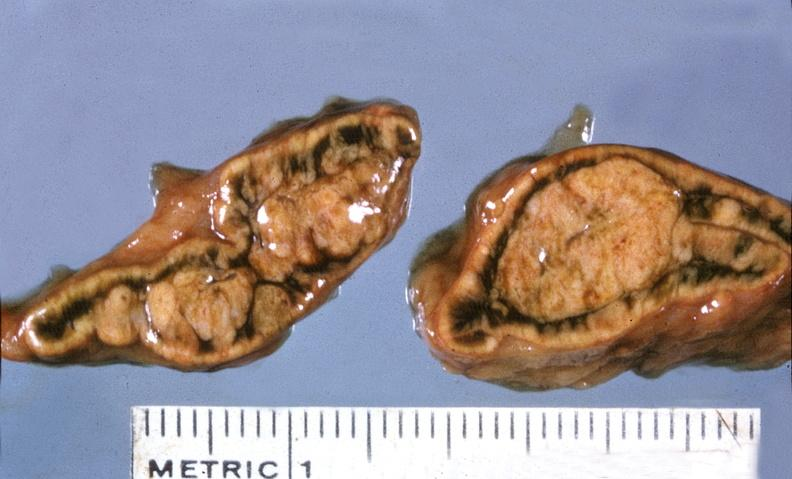what does this image show?
Answer the question using a single word or phrase. Adrenal 